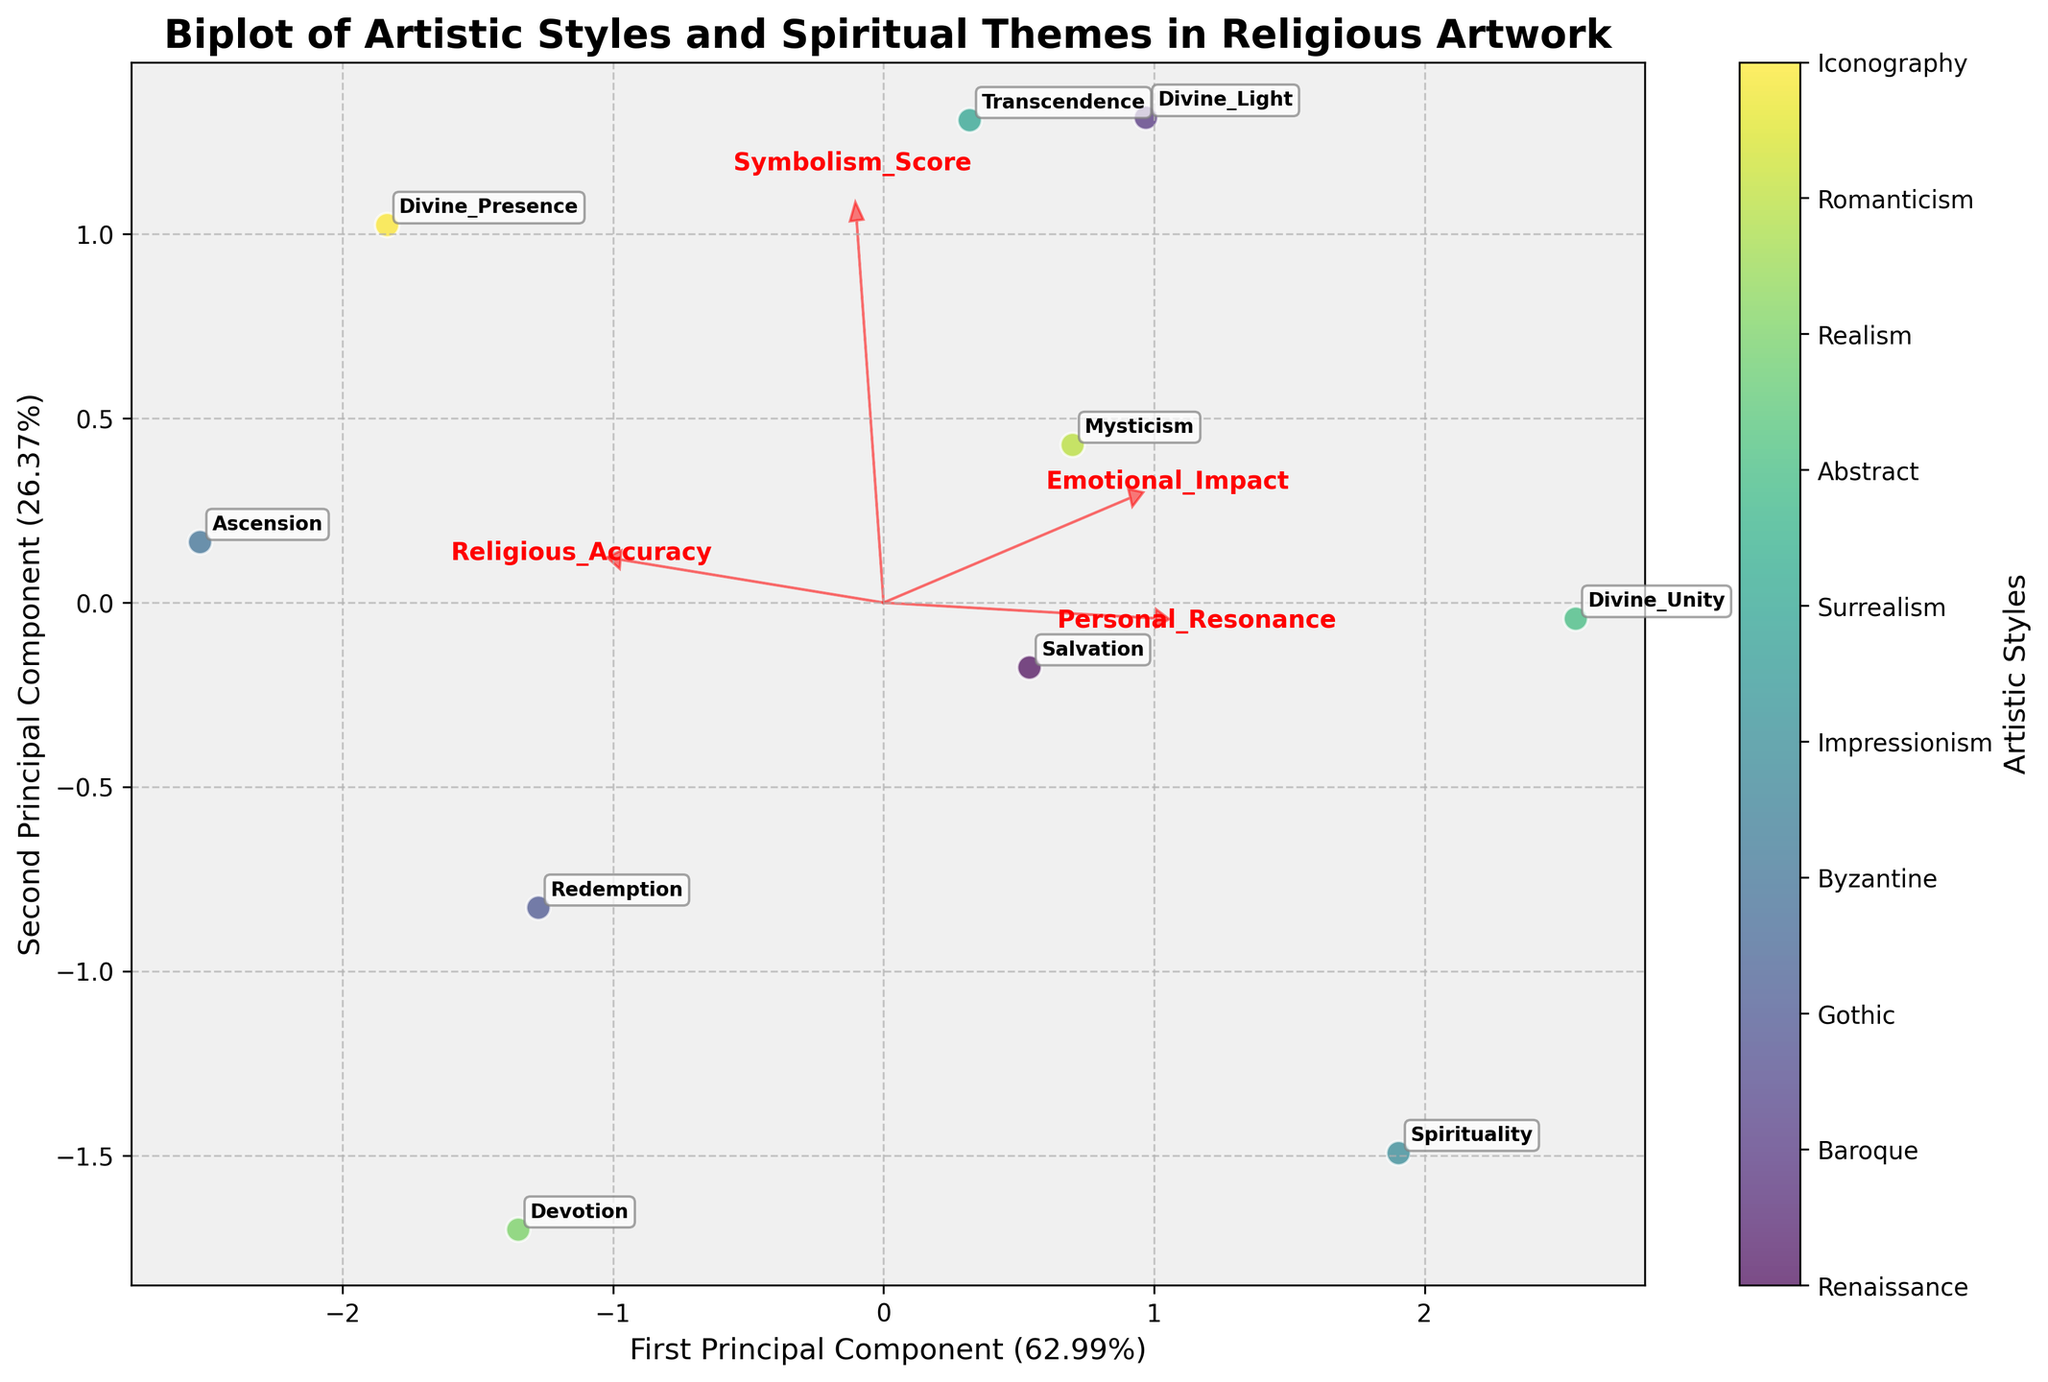How many principal components are shown in the plot? The plot shows two principal components, which are often used in a biplot to visualize data in two dimensions. Look at the x-axis and y-axis labels stating "First Principal Component" and "Second Principal Component".
Answer: 2 Which artistic style has the highest Personal Resonance according to the plot? To find the artistic style with the highest Personal Resonance, note the feature vector labeled "Personal_Resonance" and see which data point aligns closely with its direction. The "Abstract" style aligns most with this vector.
Answer: Abstract What percentage of the variance is explained by the first principal component? The x-axis is labeled "First Principal Component" followed by the percentage in parentheses. Looking at this label tells us that it explains 62.68% of the variance.
Answer: 62.68% Which data points are closest in the plot, indicating similar characteristics? By examining the distances between data points, we see the pairs "Baroque" and "Abstract" as well as "Renaissance" and "Gothic" being quite close to each other, representing similar characteristics.
Answer: Baroque & Abstract, Renaissance & Gothic How do the vectors for Symbolism_Score and Emotional_Impact compare in the plot? The direction and length of the vectors for "Symbolism_Score" and "Emotional_Impact" determine their influence. The vectors are relatively aligned, suggesting that these two features are correlated and similarly influence the components.
Answer: They are aligned Which spiritual theme is associated with Byzantine artwork in the plot? The spiritual theme associated with Byzantine artwork is labeled next to its plot point. According to the plot, the theme closest to Byzantine is "Ascension".
Answer: Ascension Which feature has the largest influence on the second principal component? By observing the vector directions and lengths, we notice that "Emotional_Impact" has the longest arrow in the direction of the y-axis, implying it has the largest influence on the second principal component.
Answer: Emotional_Impact What is the approximate color assigned to the Gothic artistic style? Looking at the colorbar and finding the position of "Gothic" artwork in the scatter plot, we see that it is assigned approximately a turquoise color.
Answer: Turquoise Which artistic style has the highest Symbolism_Score? The vector labeled "Symbolism_Score" points in a specific direction, indicating higher scores. The plot point farthest in that direction belongs to "Surrealism", indicating the highest Symbolism_Score.
Answer: Surrealism Do Emotional_Impact and Religious_Accuracy seem correlated in this biplot? Observing the direction and proximity of the vectors for "Emotional_Impact" and "Religious_Accuracy", we see that they are relatively aligned and close, suggesting a positive correlation.
Answer: Yes 